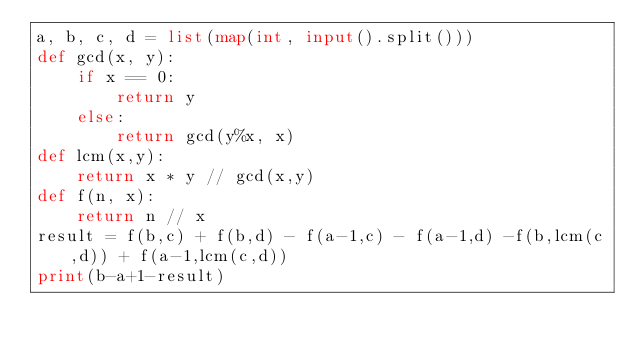Convert code to text. <code><loc_0><loc_0><loc_500><loc_500><_Python_>a, b, c, d = list(map(int, input().split()))
def gcd(x, y):
    if x == 0:
        return y
    else:
        return gcd(y%x, x)
def lcm(x,y):
    return x * y // gcd(x,y)
def f(n, x):
    return n // x
result = f(b,c) + f(b,d) - f(a-1,c) - f(a-1,d) -f(b,lcm(c,d)) + f(a-1,lcm(c,d))
print(b-a+1-result)</code> 